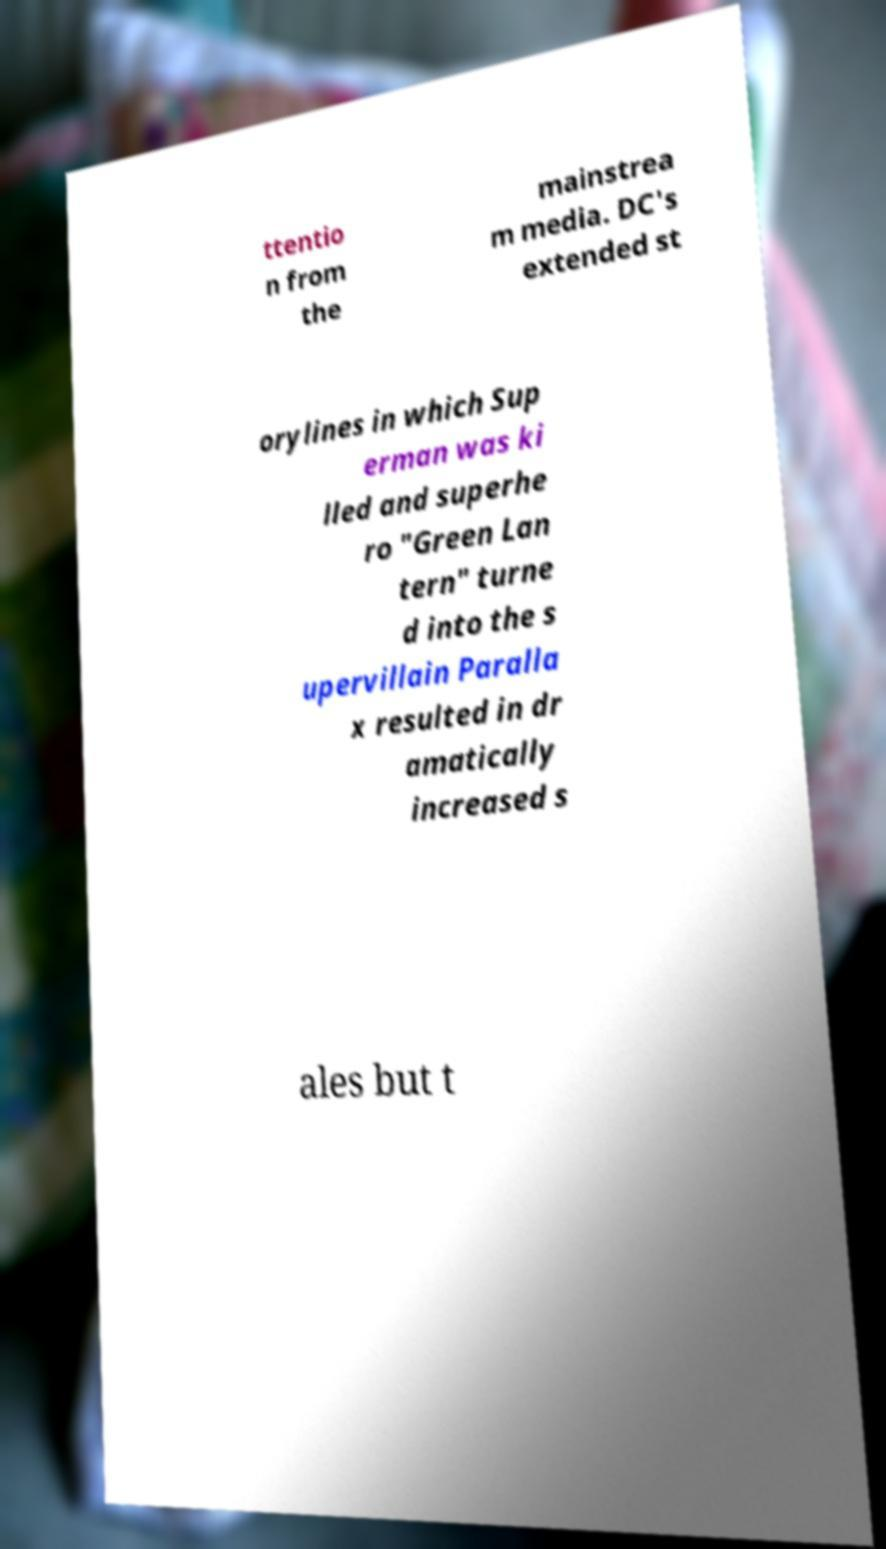Please identify and transcribe the text found in this image. ttentio n from the mainstrea m media. DC's extended st orylines in which Sup erman was ki lled and superhe ro "Green Lan tern" turne d into the s upervillain Paralla x resulted in dr amatically increased s ales but t 